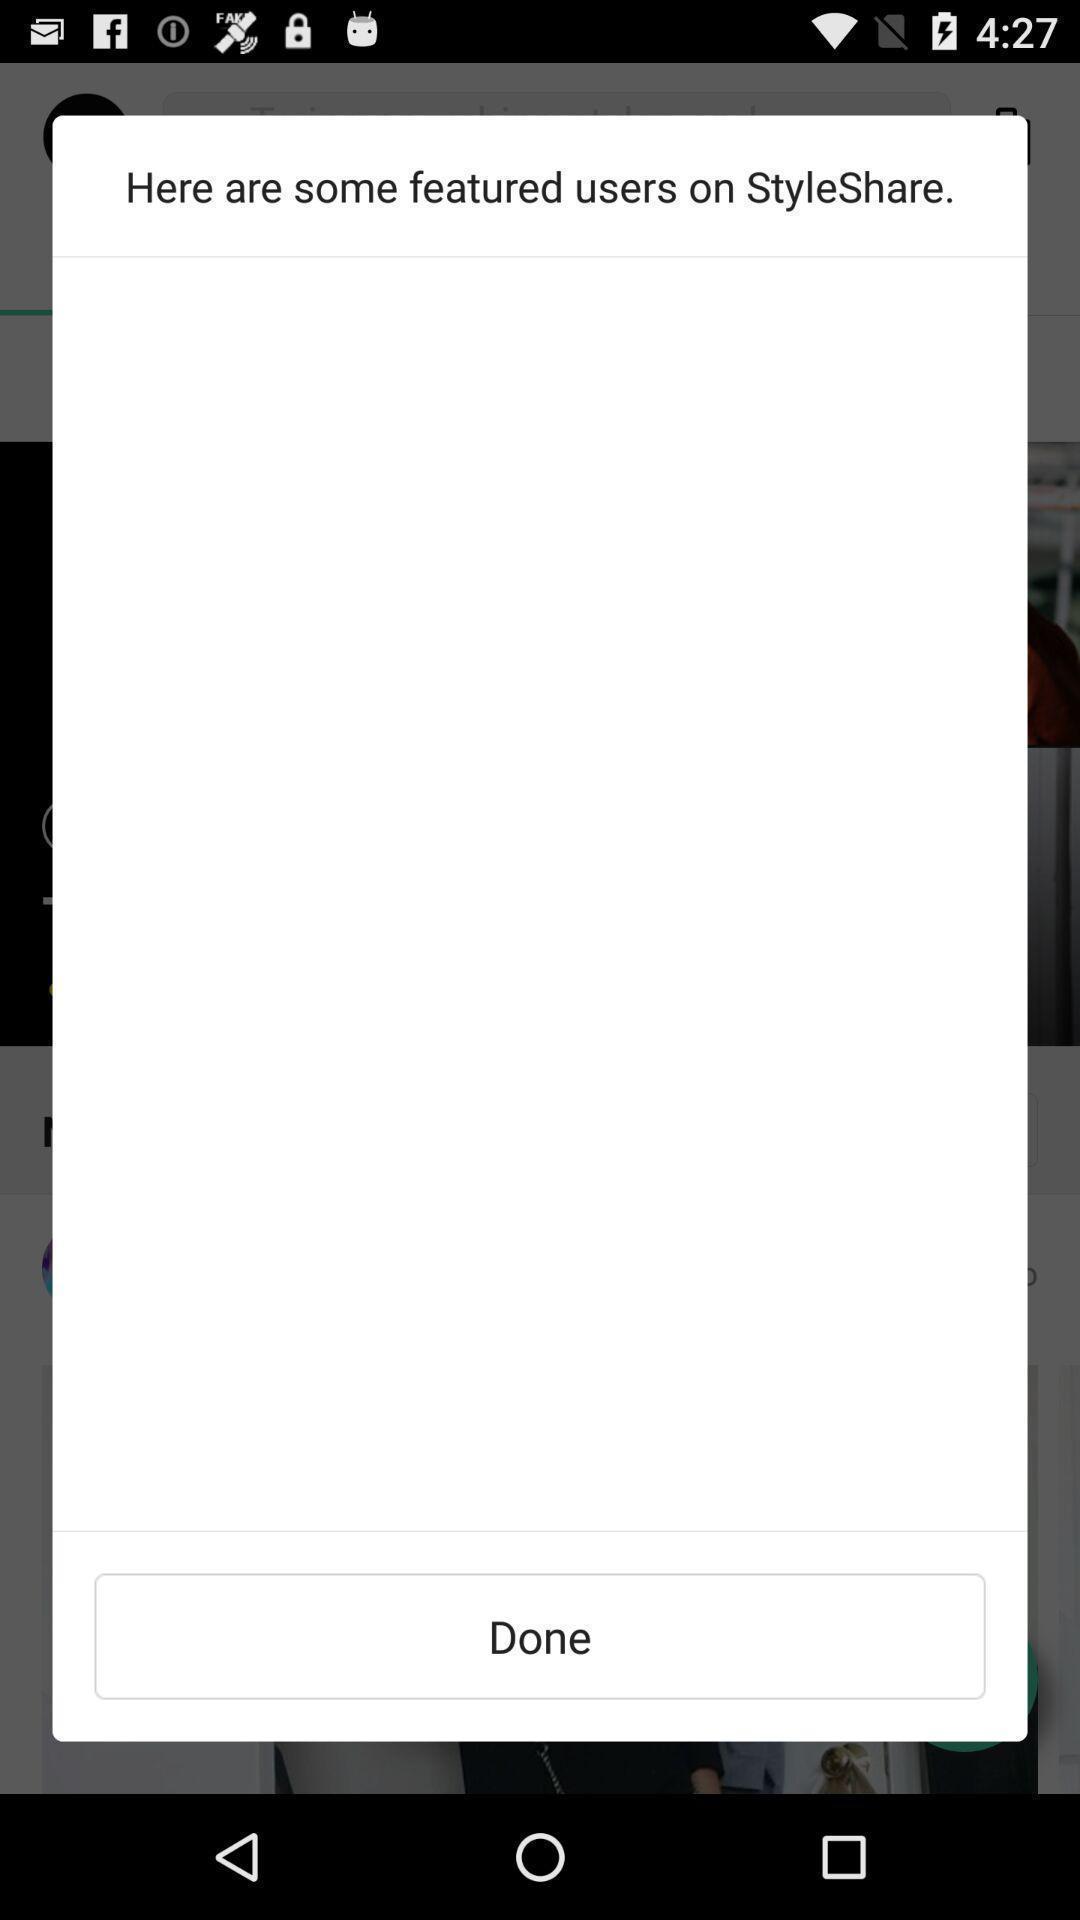Describe this image in words. Screen showing featured users. 